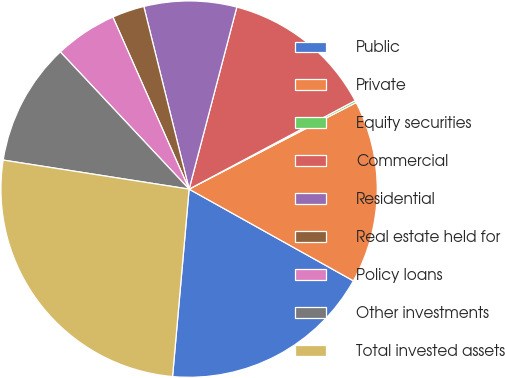<chart> <loc_0><loc_0><loc_500><loc_500><pie_chart><fcel>Public<fcel>Private<fcel>Equity securities<fcel>Commercial<fcel>Residential<fcel>Real estate held for<fcel>Policy loans<fcel>Other investments<fcel>Total invested assets<nl><fcel>18.3%<fcel>15.72%<fcel>0.18%<fcel>13.13%<fcel>7.95%<fcel>2.77%<fcel>5.36%<fcel>10.54%<fcel>26.07%<nl></chart> 